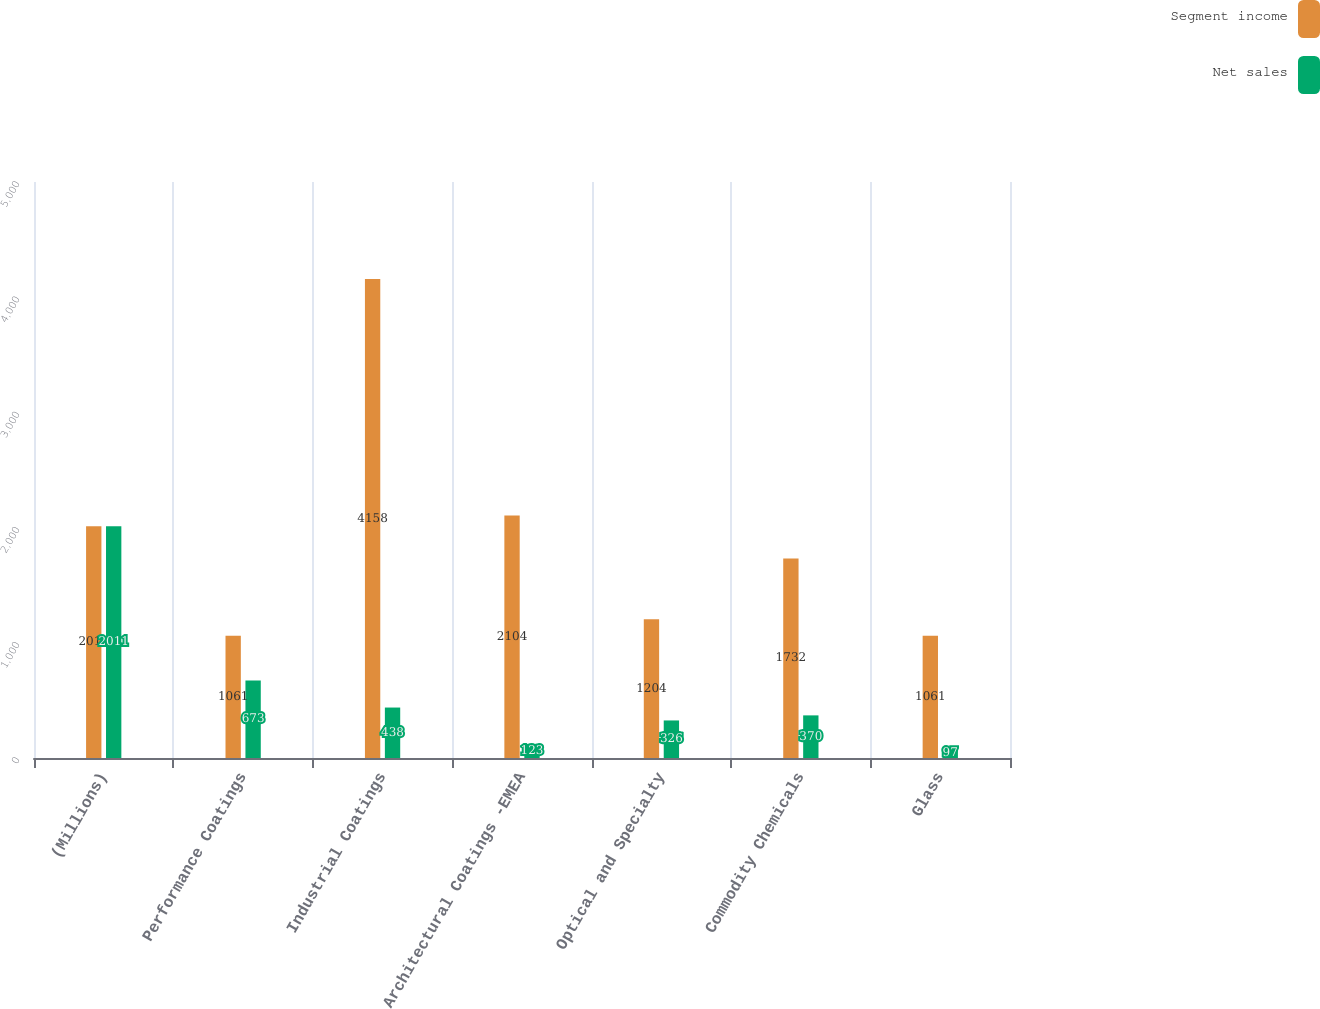Convert chart to OTSL. <chart><loc_0><loc_0><loc_500><loc_500><stacked_bar_chart><ecel><fcel>(Millions)<fcel>Performance Coatings<fcel>Industrial Coatings<fcel>Architectural Coatings -EMEA<fcel>Optical and Specialty<fcel>Commodity Chemicals<fcel>Glass<nl><fcel>Segment income<fcel>2011<fcel>1061<fcel>4158<fcel>2104<fcel>1204<fcel>1732<fcel>1061<nl><fcel>Net sales<fcel>2011<fcel>673<fcel>438<fcel>123<fcel>326<fcel>370<fcel>97<nl></chart> 